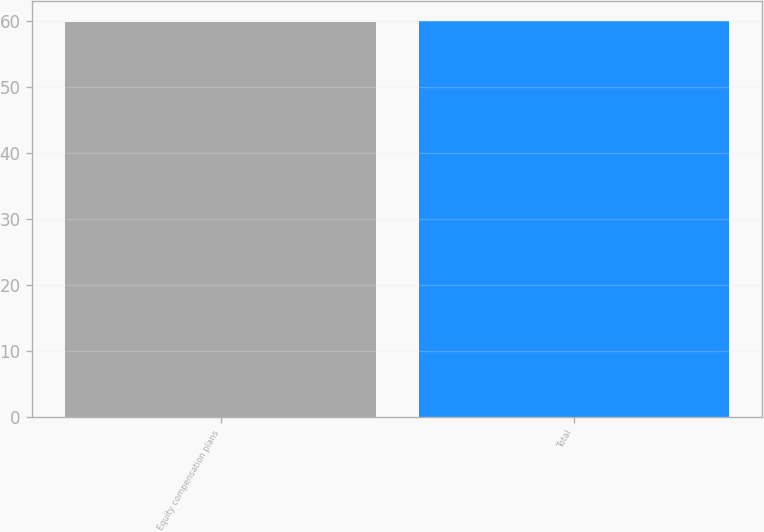Convert chart. <chart><loc_0><loc_0><loc_500><loc_500><bar_chart><fcel>Equity compensation plans<fcel>Total<nl><fcel>59.93<fcel>60.03<nl></chart> 